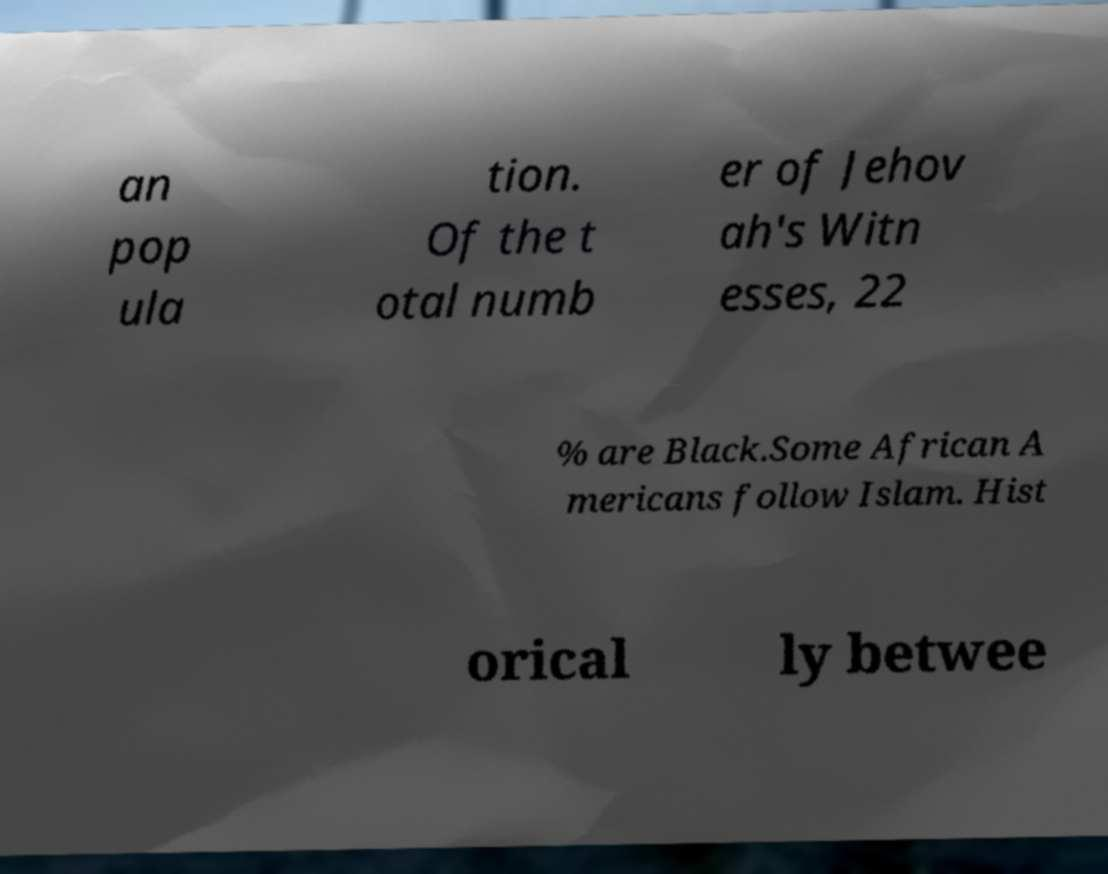Could you extract and type out the text from this image? an pop ula tion. Of the t otal numb er of Jehov ah's Witn esses, 22 % are Black.Some African A mericans follow Islam. Hist orical ly betwee 